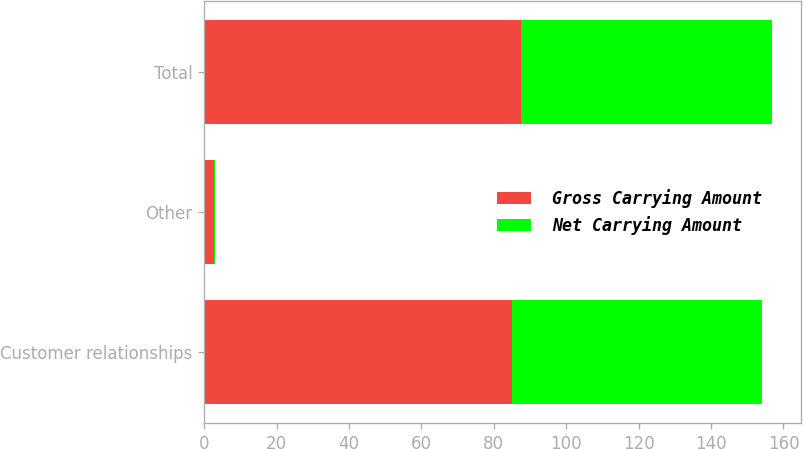Convert chart to OTSL. <chart><loc_0><loc_0><loc_500><loc_500><stacked_bar_chart><ecel><fcel>Customer relationships<fcel>Other<fcel>Total<nl><fcel>Gross Carrying Amount<fcel>85<fcel>2.6<fcel>87.6<nl><fcel>Net Carrying Amount<fcel>69<fcel>0.3<fcel>69.3<nl></chart> 